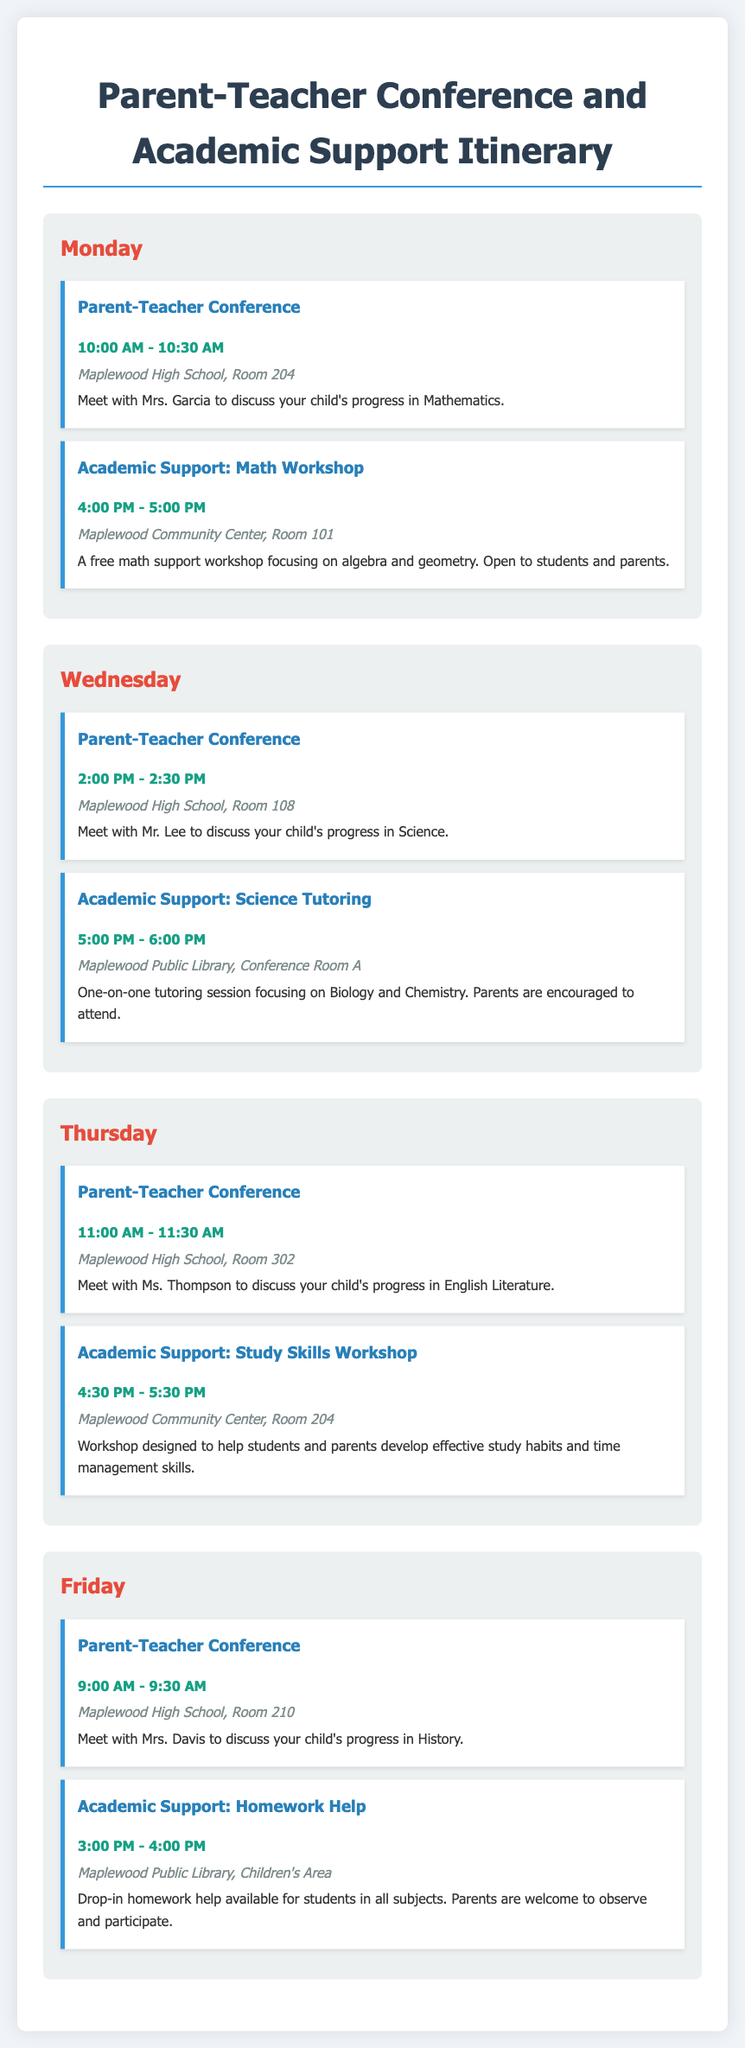What time is the Parent-Teacher Conference on Monday? The time for the Parent-Teacher Conference on Monday is mentioned, which is from 10:00 AM to 10:30 AM.
Answer: 10:00 AM - 10:30 AM Who is the teacher for the Science Conference on Wednesday? The teacher mentioned for the Science Conference on Wednesday is Mr. Lee.
Answer: Mr. Lee What is the location for the Math Workshop? The location for the Math Workshop is identified, which is the Maplewood Community Center, Room 101.
Answer: Maplewood Community Center, Room 101 How long is the Study Skills Workshop on Thursday? The duration of the Study Skills Workshop is determined, which runs for one hour, from 4:30 PM to 5:30 PM.
Answer: 1 hour What subject does Mrs. Davis teach? The subject Mrs. Davis teaches is referenced in the document, which is History.
Answer: History How many Parent-Teacher Conferences are scheduled for this week? The document lists the number of Parent-Teacher Conferences that occur over the week, which total four sessions.
Answer: Four Where is the Homework Help session held on Friday? The location for the Homework Help session on Friday is specified, which is the Children's Area of Maplewood Public Library.
Answer: Maplewood Public Library, Children's Area What is the focus of the Academic Support sessions? The Academic Support sessions cover specific subjects or skills, such as Math, Science, and Study Skills, as indicated in the document.
Answer: Math, Science, Study Skills When is the last scheduled session of the week? The last session of the week is identified as the Homework Help session on Friday from 3:00 PM to 4:00 PM.
Answer: 3:00 PM - 4:00 PM 